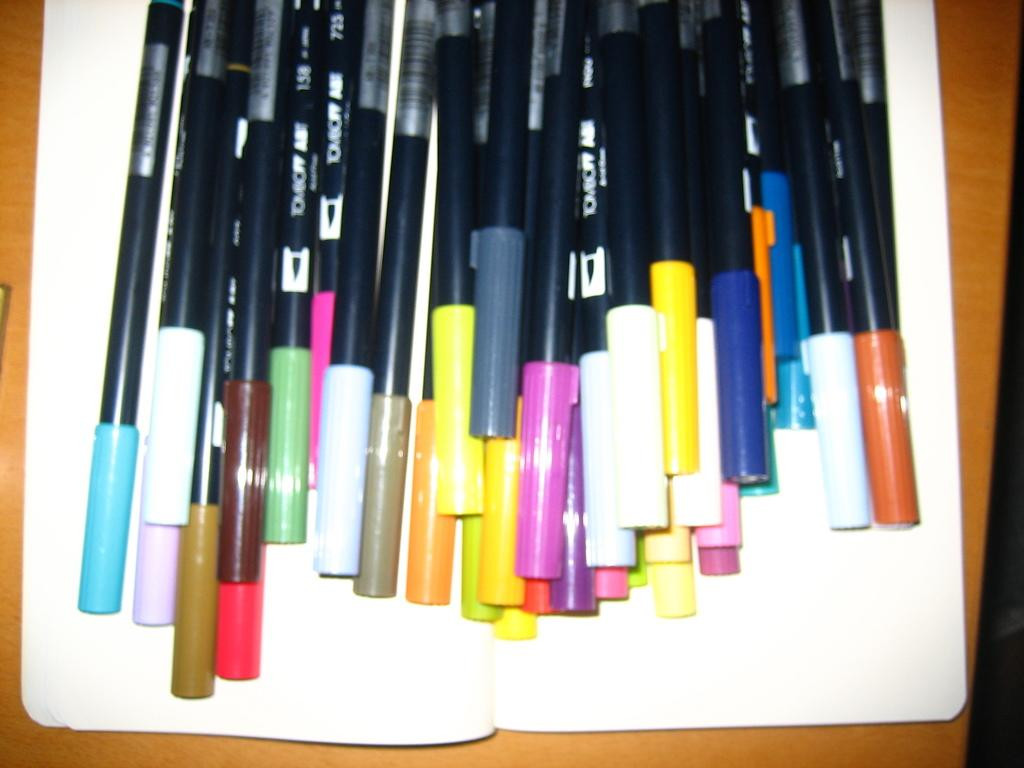What is the color of the main object in the image? The main object in the image is white. What can be found on the white object? There are sketch pens on the white object. Can you describe the leaf pattern on the rail in the image? There is no leaf pattern or rail present in the image; it only features a white object with sketch pens on it. 